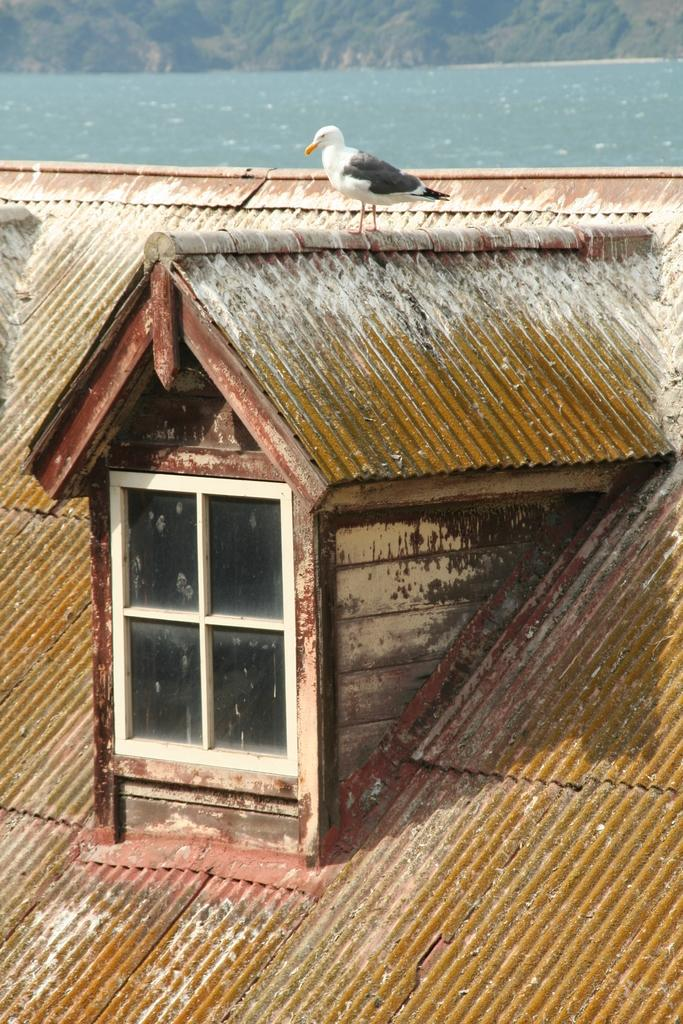What is the main subject in the center of the image? There is a bird in the center of the image. What else is located in the center of the image? There is a window and a shed in the center of the image. What can be seen in the background of the image? Water and a hill are visible in the background of the image. What type of cast can be seen on the bird's wing in the image? There is no cast visible on the bird's wing in the image; the bird appears to be uninjured. 